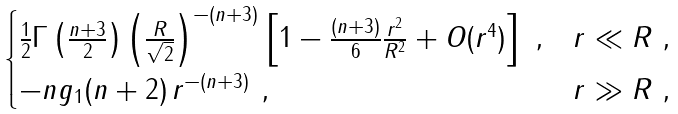<formula> <loc_0><loc_0><loc_500><loc_500>\begin{cases} \frac { 1 } { 2 } \Gamma \left ( \frac { n + 3 } { 2 } \right ) \left ( \frac { R } { \sqrt { 2 } } \right ) ^ { - ( n + 3 ) } \left [ 1 - \frac { ( n + 3 ) } { 6 } \frac { r ^ { 2 } } { R ^ { 2 } } + O ( r ^ { 4 } ) \right ] \ , & r \ll R \ , \\ - n g _ { 1 } ( n + 2 ) \, r ^ { - ( n + 3 ) } \ , & r \gg R \ , \end{cases}</formula> 